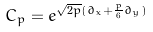<formula> <loc_0><loc_0><loc_500><loc_500>C _ { p } = e ^ { \sqrt { 2 p } ( \partial _ { x } + \frac { p } { 6 } \partial _ { y } ) }</formula> 